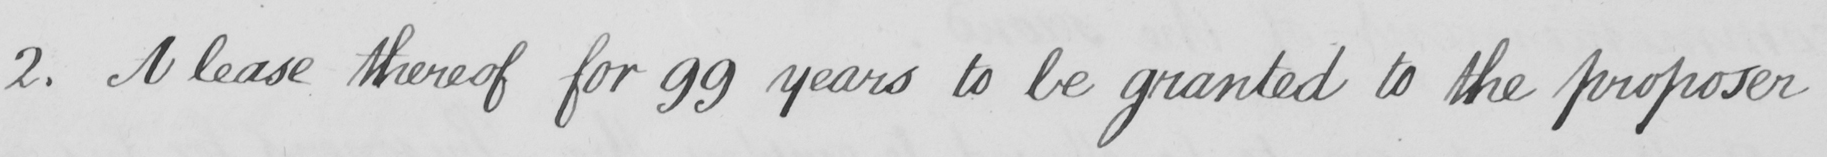Please provide the text content of this handwritten line. 2 . A lease thereof for 99 years to be granted to the proposer 